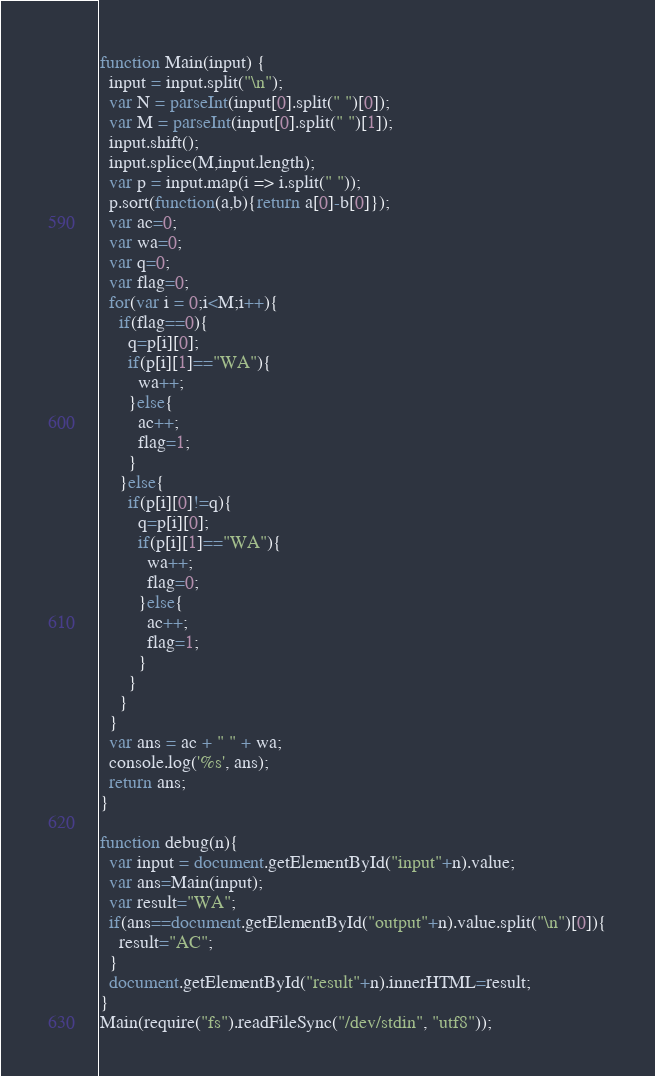<code> <loc_0><loc_0><loc_500><loc_500><_JavaScript_>function Main(input) {
  input = input.split("\n");
  var N = parseInt(input[0].split(" ")[0]);
  var M = parseInt(input[0].split(" ")[1]);
  input.shift();
  input.splice(M,input.length);
  var p = input.map(i => i.split(" "));
  p.sort(function(a,b){return a[0]-b[0]});
  var ac=0;
  var wa=0;
  var q=0;
  var flag=0;
  for(var i = 0;i<M;i++){
    if(flag==0){
      q=p[i][0];
      if(p[i][1]=="WA"){
        wa++;
      }else{
        ac++;
        flag=1;
      }
    }else{
      if(p[i][0]!=q){
        q=p[i][0];
        if(p[i][1]=="WA"){
          wa++;
          flag=0;
        }else{
          ac++;
          flag=1;
        }
      }
    }
  }
  var ans = ac + " " + wa;
  console.log('%s', ans);
  return ans;
}

function debug(n){
  var input = document.getElementById("input"+n).value;
  var ans=Main(input);
  var result="WA";
  if(ans==document.getElementById("output"+n).value.split("\n")[0]){
    result="AC";
  }
  document.getElementById("result"+n).innerHTML=result;
}
Main(require("fs").readFileSync("/dev/stdin", "utf8"));</code> 